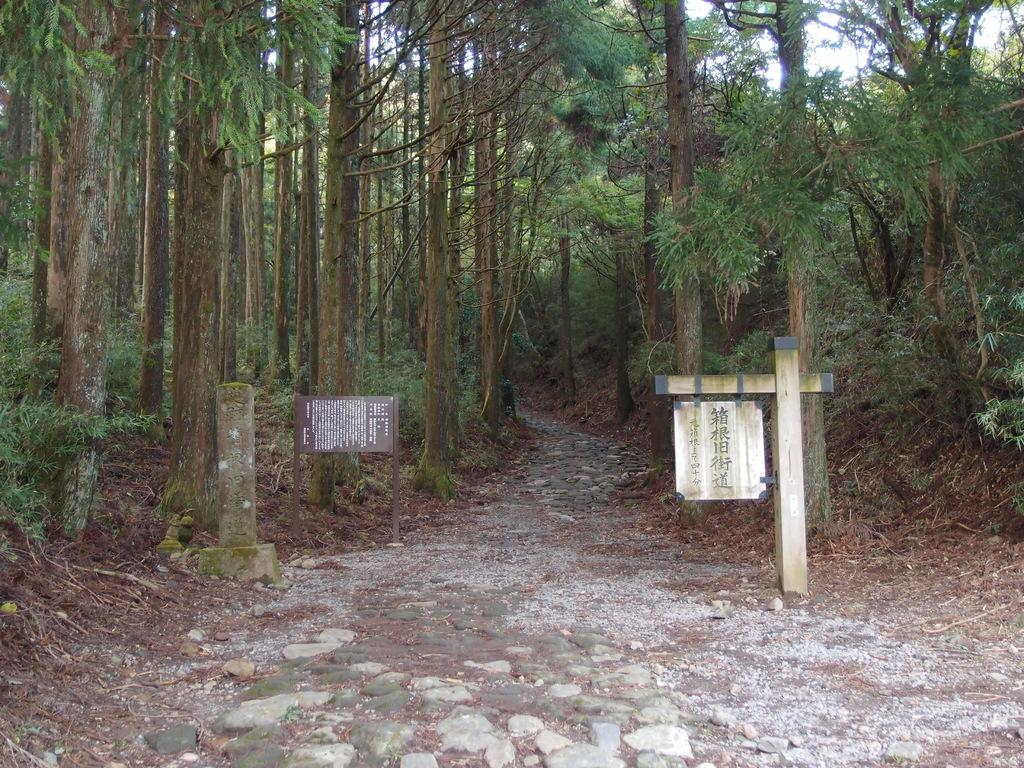What can be seen on the poles in the image? There are sign boards on poles in the image. What information is provided on the sign boards? The sign boards have text on them. What type of surface can be seen in the image? There are stones visible in the image. What kind of route is depicted in the image? There is a pathway in the image. What part of the trees is visible in the image? The bark of trees is visible in the image. How many trees are grouped together in the image? There is a group of trees in the image. What part of the natural environment is visible in the image? The sky is visible in the image. What type of knife is being used to cut the guide in the image? There is no knife or guide present in the image. What is the taste of the sign boards in the image? Sign boards do not have a taste, as they are made of materials like metal or plastic and display text or images. 